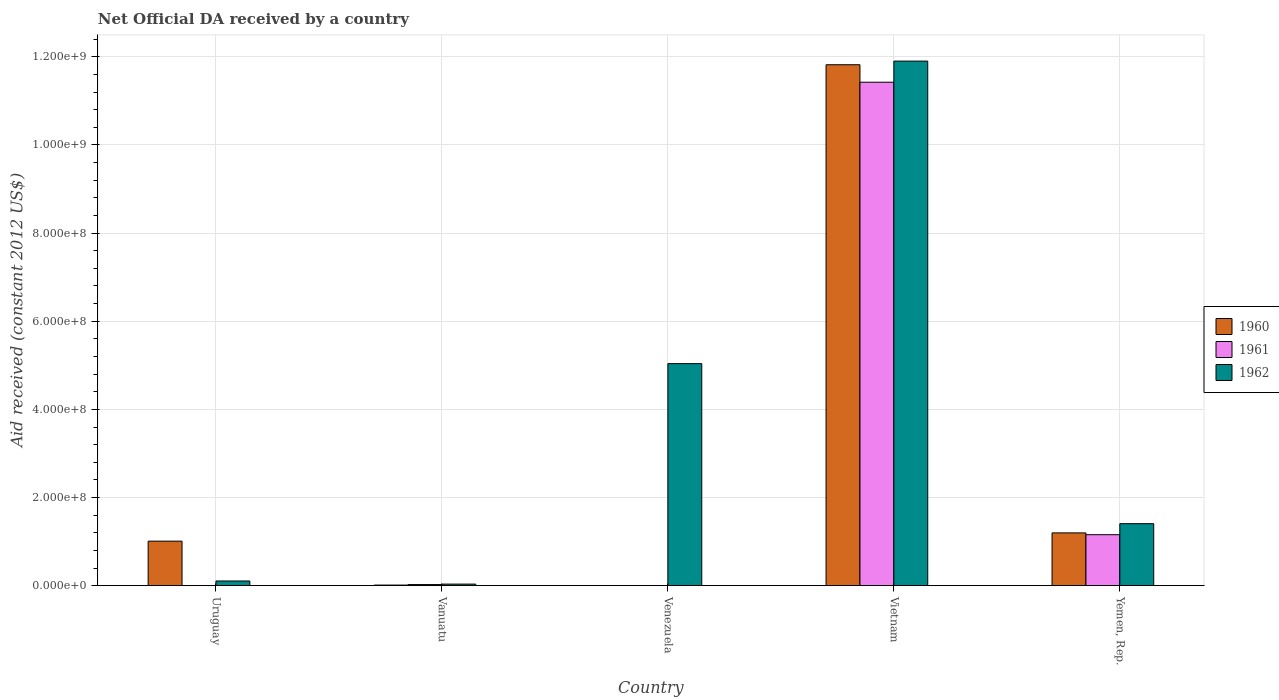How many different coloured bars are there?
Offer a very short reply. 3. Are the number of bars on each tick of the X-axis equal?
Offer a terse response. No. How many bars are there on the 5th tick from the left?
Your answer should be very brief. 3. What is the label of the 2nd group of bars from the left?
Make the answer very short. Vanuatu. In how many cases, is the number of bars for a given country not equal to the number of legend labels?
Your answer should be compact. 2. What is the net official development assistance aid received in 1961 in Vietnam?
Offer a terse response. 1.14e+09. Across all countries, what is the maximum net official development assistance aid received in 1960?
Ensure brevity in your answer.  1.18e+09. In which country was the net official development assistance aid received in 1962 maximum?
Make the answer very short. Vietnam. What is the total net official development assistance aid received in 1960 in the graph?
Offer a very short reply. 1.40e+09. What is the difference between the net official development assistance aid received in 1962 in Vanuatu and that in Yemen, Rep.?
Provide a succinct answer. -1.37e+08. What is the difference between the net official development assistance aid received in 1962 in Vanuatu and the net official development assistance aid received in 1961 in Uruguay?
Provide a succinct answer. 3.58e+06. What is the average net official development assistance aid received in 1960 per country?
Your answer should be very brief. 2.81e+08. What is the difference between the net official development assistance aid received of/in 1960 and net official development assistance aid received of/in 1962 in Yemen, Rep.?
Make the answer very short. -2.09e+07. What is the ratio of the net official development assistance aid received in 1962 in Uruguay to that in Vanuatu?
Your answer should be very brief. 2.97. Is the net official development assistance aid received in 1962 in Vanuatu less than that in Yemen, Rep.?
Your response must be concise. Yes. Is the difference between the net official development assistance aid received in 1960 in Uruguay and Vietnam greater than the difference between the net official development assistance aid received in 1962 in Uruguay and Vietnam?
Give a very brief answer. Yes. What is the difference between the highest and the second highest net official development assistance aid received in 1961?
Make the answer very short. 1.03e+09. What is the difference between the highest and the lowest net official development assistance aid received in 1961?
Your answer should be very brief. 1.14e+09. How many bars are there?
Your response must be concise. 12. How many countries are there in the graph?
Ensure brevity in your answer.  5. What is the difference between two consecutive major ticks on the Y-axis?
Offer a terse response. 2.00e+08. Does the graph contain any zero values?
Offer a very short reply. Yes. Where does the legend appear in the graph?
Your response must be concise. Center right. What is the title of the graph?
Provide a succinct answer. Net Official DA received by a country. Does "1972" appear as one of the legend labels in the graph?
Offer a terse response. No. What is the label or title of the Y-axis?
Give a very brief answer. Aid received (constant 2012 US$). What is the Aid received (constant 2012 US$) in 1960 in Uruguay?
Provide a succinct answer. 1.01e+08. What is the Aid received (constant 2012 US$) of 1961 in Uruguay?
Provide a short and direct response. 0. What is the Aid received (constant 2012 US$) in 1962 in Uruguay?
Ensure brevity in your answer.  1.06e+07. What is the Aid received (constant 2012 US$) of 1960 in Vanuatu?
Provide a succinct answer. 1.39e+06. What is the Aid received (constant 2012 US$) of 1961 in Vanuatu?
Your answer should be very brief. 2.53e+06. What is the Aid received (constant 2012 US$) in 1962 in Vanuatu?
Your response must be concise. 3.58e+06. What is the Aid received (constant 2012 US$) of 1960 in Venezuela?
Keep it short and to the point. 0. What is the Aid received (constant 2012 US$) in 1962 in Venezuela?
Provide a short and direct response. 5.04e+08. What is the Aid received (constant 2012 US$) in 1960 in Vietnam?
Provide a short and direct response. 1.18e+09. What is the Aid received (constant 2012 US$) in 1961 in Vietnam?
Ensure brevity in your answer.  1.14e+09. What is the Aid received (constant 2012 US$) of 1962 in Vietnam?
Your answer should be compact. 1.19e+09. What is the Aid received (constant 2012 US$) of 1960 in Yemen, Rep.?
Provide a short and direct response. 1.20e+08. What is the Aid received (constant 2012 US$) in 1961 in Yemen, Rep.?
Your answer should be compact. 1.16e+08. What is the Aid received (constant 2012 US$) of 1962 in Yemen, Rep.?
Provide a short and direct response. 1.41e+08. Across all countries, what is the maximum Aid received (constant 2012 US$) of 1960?
Your answer should be very brief. 1.18e+09. Across all countries, what is the maximum Aid received (constant 2012 US$) of 1961?
Your response must be concise. 1.14e+09. Across all countries, what is the maximum Aid received (constant 2012 US$) of 1962?
Keep it short and to the point. 1.19e+09. Across all countries, what is the minimum Aid received (constant 2012 US$) of 1962?
Provide a succinct answer. 3.58e+06. What is the total Aid received (constant 2012 US$) of 1960 in the graph?
Your response must be concise. 1.40e+09. What is the total Aid received (constant 2012 US$) of 1961 in the graph?
Your answer should be very brief. 1.26e+09. What is the total Aid received (constant 2012 US$) in 1962 in the graph?
Make the answer very short. 1.85e+09. What is the difference between the Aid received (constant 2012 US$) of 1960 in Uruguay and that in Vanuatu?
Your answer should be compact. 9.97e+07. What is the difference between the Aid received (constant 2012 US$) of 1962 in Uruguay and that in Vanuatu?
Make the answer very short. 7.07e+06. What is the difference between the Aid received (constant 2012 US$) of 1962 in Uruguay and that in Venezuela?
Ensure brevity in your answer.  -4.93e+08. What is the difference between the Aid received (constant 2012 US$) of 1960 in Uruguay and that in Vietnam?
Offer a very short reply. -1.08e+09. What is the difference between the Aid received (constant 2012 US$) in 1962 in Uruguay and that in Vietnam?
Provide a succinct answer. -1.18e+09. What is the difference between the Aid received (constant 2012 US$) of 1960 in Uruguay and that in Yemen, Rep.?
Make the answer very short. -1.87e+07. What is the difference between the Aid received (constant 2012 US$) in 1962 in Uruguay and that in Yemen, Rep.?
Your response must be concise. -1.30e+08. What is the difference between the Aid received (constant 2012 US$) of 1962 in Vanuatu and that in Venezuela?
Offer a terse response. -5.00e+08. What is the difference between the Aid received (constant 2012 US$) in 1960 in Vanuatu and that in Vietnam?
Provide a short and direct response. -1.18e+09. What is the difference between the Aid received (constant 2012 US$) in 1961 in Vanuatu and that in Vietnam?
Make the answer very short. -1.14e+09. What is the difference between the Aid received (constant 2012 US$) in 1962 in Vanuatu and that in Vietnam?
Offer a terse response. -1.19e+09. What is the difference between the Aid received (constant 2012 US$) in 1960 in Vanuatu and that in Yemen, Rep.?
Provide a short and direct response. -1.18e+08. What is the difference between the Aid received (constant 2012 US$) in 1961 in Vanuatu and that in Yemen, Rep.?
Keep it short and to the point. -1.13e+08. What is the difference between the Aid received (constant 2012 US$) of 1962 in Vanuatu and that in Yemen, Rep.?
Ensure brevity in your answer.  -1.37e+08. What is the difference between the Aid received (constant 2012 US$) of 1962 in Venezuela and that in Vietnam?
Provide a succinct answer. -6.86e+08. What is the difference between the Aid received (constant 2012 US$) of 1962 in Venezuela and that in Yemen, Rep.?
Your answer should be compact. 3.63e+08. What is the difference between the Aid received (constant 2012 US$) in 1960 in Vietnam and that in Yemen, Rep.?
Provide a short and direct response. 1.06e+09. What is the difference between the Aid received (constant 2012 US$) of 1961 in Vietnam and that in Yemen, Rep.?
Give a very brief answer. 1.03e+09. What is the difference between the Aid received (constant 2012 US$) in 1962 in Vietnam and that in Yemen, Rep.?
Your response must be concise. 1.05e+09. What is the difference between the Aid received (constant 2012 US$) in 1960 in Uruguay and the Aid received (constant 2012 US$) in 1961 in Vanuatu?
Give a very brief answer. 9.85e+07. What is the difference between the Aid received (constant 2012 US$) in 1960 in Uruguay and the Aid received (constant 2012 US$) in 1962 in Vanuatu?
Your answer should be very brief. 9.75e+07. What is the difference between the Aid received (constant 2012 US$) of 1960 in Uruguay and the Aid received (constant 2012 US$) of 1962 in Venezuela?
Make the answer very short. -4.03e+08. What is the difference between the Aid received (constant 2012 US$) of 1960 in Uruguay and the Aid received (constant 2012 US$) of 1961 in Vietnam?
Make the answer very short. -1.04e+09. What is the difference between the Aid received (constant 2012 US$) in 1960 in Uruguay and the Aid received (constant 2012 US$) in 1962 in Vietnam?
Provide a succinct answer. -1.09e+09. What is the difference between the Aid received (constant 2012 US$) of 1960 in Uruguay and the Aid received (constant 2012 US$) of 1961 in Yemen, Rep.?
Offer a terse response. -1.46e+07. What is the difference between the Aid received (constant 2012 US$) in 1960 in Uruguay and the Aid received (constant 2012 US$) in 1962 in Yemen, Rep.?
Your response must be concise. -3.96e+07. What is the difference between the Aid received (constant 2012 US$) in 1960 in Vanuatu and the Aid received (constant 2012 US$) in 1962 in Venezuela?
Your answer should be compact. -5.02e+08. What is the difference between the Aid received (constant 2012 US$) in 1961 in Vanuatu and the Aid received (constant 2012 US$) in 1962 in Venezuela?
Your answer should be compact. -5.01e+08. What is the difference between the Aid received (constant 2012 US$) in 1960 in Vanuatu and the Aid received (constant 2012 US$) in 1961 in Vietnam?
Keep it short and to the point. -1.14e+09. What is the difference between the Aid received (constant 2012 US$) in 1960 in Vanuatu and the Aid received (constant 2012 US$) in 1962 in Vietnam?
Your response must be concise. -1.19e+09. What is the difference between the Aid received (constant 2012 US$) of 1961 in Vanuatu and the Aid received (constant 2012 US$) of 1962 in Vietnam?
Your answer should be very brief. -1.19e+09. What is the difference between the Aid received (constant 2012 US$) in 1960 in Vanuatu and the Aid received (constant 2012 US$) in 1961 in Yemen, Rep.?
Offer a very short reply. -1.14e+08. What is the difference between the Aid received (constant 2012 US$) in 1960 in Vanuatu and the Aid received (constant 2012 US$) in 1962 in Yemen, Rep.?
Offer a very short reply. -1.39e+08. What is the difference between the Aid received (constant 2012 US$) of 1961 in Vanuatu and the Aid received (constant 2012 US$) of 1962 in Yemen, Rep.?
Provide a succinct answer. -1.38e+08. What is the difference between the Aid received (constant 2012 US$) of 1960 in Vietnam and the Aid received (constant 2012 US$) of 1961 in Yemen, Rep.?
Provide a succinct answer. 1.07e+09. What is the difference between the Aid received (constant 2012 US$) in 1960 in Vietnam and the Aid received (constant 2012 US$) in 1962 in Yemen, Rep.?
Your answer should be very brief. 1.04e+09. What is the difference between the Aid received (constant 2012 US$) of 1961 in Vietnam and the Aid received (constant 2012 US$) of 1962 in Yemen, Rep.?
Your answer should be very brief. 1.00e+09. What is the average Aid received (constant 2012 US$) of 1960 per country?
Offer a very short reply. 2.81e+08. What is the average Aid received (constant 2012 US$) in 1961 per country?
Provide a succinct answer. 2.52e+08. What is the average Aid received (constant 2012 US$) of 1962 per country?
Your answer should be very brief. 3.70e+08. What is the difference between the Aid received (constant 2012 US$) of 1960 and Aid received (constant 2012 US$) of 1962 in Uruguay?
Offer a very short reply. 9.04e+07. What is the difference between the Aid received (constant 2012 US$) of 1960 and Aid received (constant 2012 US$) of 1961 in Vanuatu?
Give a very brief answer. -1.14e+06. What is the difference between the Aid received (constant 2012 US$) of 1960 and Aid received (constant 2012 US$) of 1962 in Vanuatu?
Your response must be concise. -2.19e+06. What is the difference between the Aid received (constant 2012 US$) in 1961 and Aid received (constant 2012 US$) in 1962 in Vanuatu?
Offer a very short reply. -1.05e+06. What is the difference between the Aid received (constant 2012 US$) in 1960 and Aid received (constant 2012 US$) in 1961 in Vietnam?
Your answer should be compact. 3.96e+07. What is the difference between the Aid received (constant 2012 US$) in 1960 and Aid received (constant 2012 US$) in 1962 in Vietnam?
Give a very brief answer. -8.26e+06. What is the difference between the Aid received (constant 2012 US$) of 1961 and Aid received (constant 2012 US$) of 1962 in Vietnam?
Your response must be concise. -4.79e+07. What is the difference between the Aid received (constant 2012 US$) in 1960 and Aid received (constant 2012 US$) in 1961 in Yemen, Rep.?
Provide a succinct answer. 4.08e+06. What is the difference between the Aid received (constant 2012 US$) in 1960 and Aid received (constant 2012 US$) in 1962 in Yemen, Rep.?
Give a very brief answer. -2.09e+07. What is the difference between the Aid received (constant 2012 US$) of 1961 and Aid received (constant 2012 US$) of 1962 in Yemen, Rep.?
Your answer should be very brief. -2.50e+07. What is the ratio of the Aid received (constant 2012 US$) of 1960 in Uruguay to that in Vanuatu?
Provide a short and direct response. 72.7. What is the ratio of the Aid received (constant 2012 US$) of 1962 in Uruguay to that in Vanuatu?
Give a very brief answer. 2.97. What is the ratio of the Aid received (constant 2012 US$) in 1962 in Uruguay to that in Venezuela?
Provide a succinct answer. 0.02. What is the ratio of the Aid received (constant 2012 US$) in 1960 in Uruguay to that in Vietnam?
Provide a short and direct response. 0.09. What is the ratio of the Aid received (constant 2012 US$) in 1962 in Uruguay to that in Vietnam?
Keep it short and to the point. 0.01. What is the ratio of the Aid received (constant 2012 US$) of 1960 in Uruguay to that in Yemen, Rep.?
Keep it short and to the point. 0.84. What is the ratio of the Aid received (constant 2012 US$) in 1962 in Uruguay to that in Yemen, Rep.?
Give a very brief answer. 0.08. What is the ratio of the Aid received (constant 2012 US$) in 1962 in Vanuatu to that in Venezuela?
Offer a very short reply. 0.01. What is the ratio of the Aid received (constant 2012 US$) of 1960 in Vanuatu to that in Vietnam?
Your answer should be very brief. 0. What is the ratio of the Aid received (constant 2012 US$) of 1961 in Vanuatu to that in Vietnam?
Make the answer very short. 0. What is the ratio of the Aid received (constant 2012 US$) of 1962 in Vanuatu to that in Vietnam?
Provide a succinct answer. 0. What is the ratio of the Aid received (constant 2012 US$) of 1960 in Vanuatu to that in Yemen, Rep.?
Provide a short and direct response. 0.01. What is the ratio of the Aid received (constant 2012 US$) in 1961 in Vanuatu to that in Yemen, Rep.?
Ensure brevity in your answer.  0.02. What is the ratio of the Aid received (constant 2012 US$) in 1962 in Vanuatu to that in Yemen, Rep.?
Offer a very short reply. 0.03. What is the ratio of the Aid received (constant 2012 US$) of 1962 in Venezuela to that in Vietnam?
Your response must be concise. 0.42. What is the ratio of the Aid received (constant 2012 US$) in 1962 in Venezuela to that in Yemen, Rep.?
Provide a short and direct response. 3.58. What is the ratio of the Aid received (constant 2012 US$) in 1960 in Vietnam to that in Yemen, Rep.?
Give a very brief answer. 9.87. What is the ratio of the Aid received (constant 2012 US$) of 1961 in Vietnam to that in Yemen, Rep.?
Ensure brevity in your answer.  9.87. What is the ratio of the Aid received (constant 2012 US$) in 1962 in Vietnam to that in Yemen, Rep.?
Your answer should be very brief. 8.46. What is the difference between the highest and the second highest Aid received (constant 2012 US$) of 1960?
Offer a very short reply. 1.06e+09. What is the difference between the highest and the second highest Aid received (constant 2012 US$) of 1961?
Your response must be concise. 1.03e+09. What is the difference between the highest and the second highest Aid received (constant 2012 US$) of 1962?
Give a very brief answer. 6.86e+08. What is the difference between the highest and the lowest Aid received (constant 2012 US$) of 1960?
Provide a short and direct response. 1.18e+09. What is the difference between the highest and the lowest Aid received (constant 2012 US$) in 1961?
Provide a short and direct response. 1.14e+09. What is the difference between the highest and the lowest Aid received (constant 2012 US$) in 1962?
Your answer should be compact. 1.19e+09. 